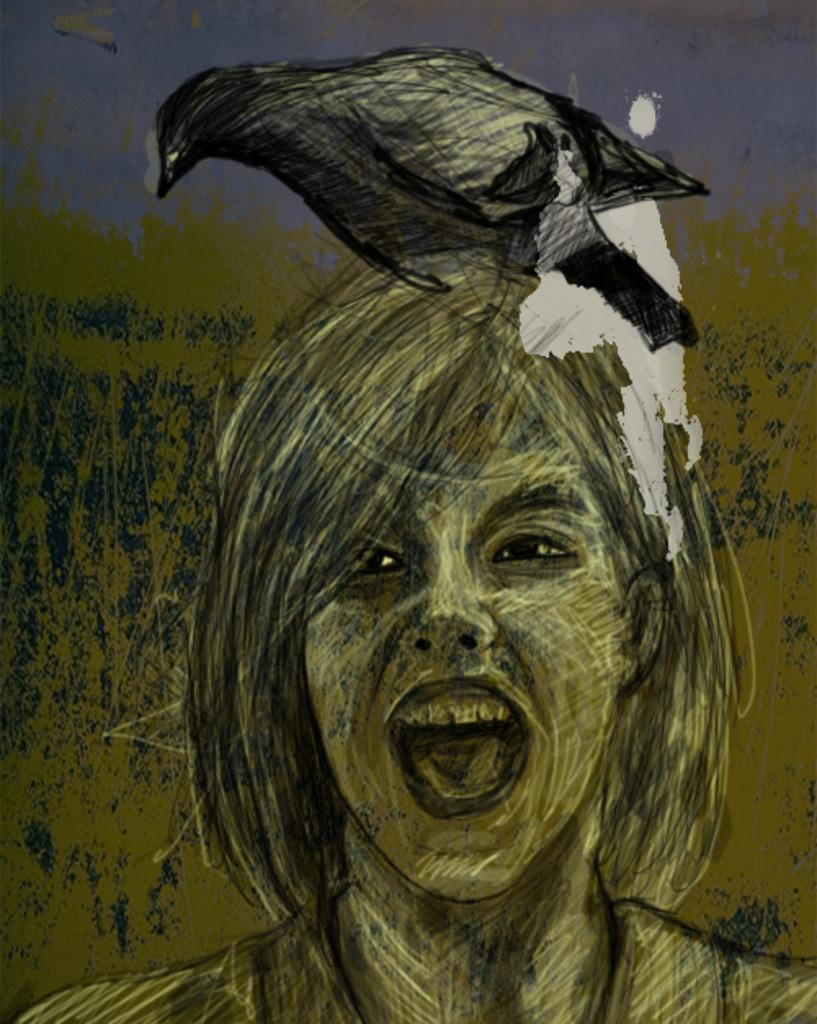Could you give a brief overview of what you see in this image? As we can see in the image there is painting of a girl, black color crow and sky. 